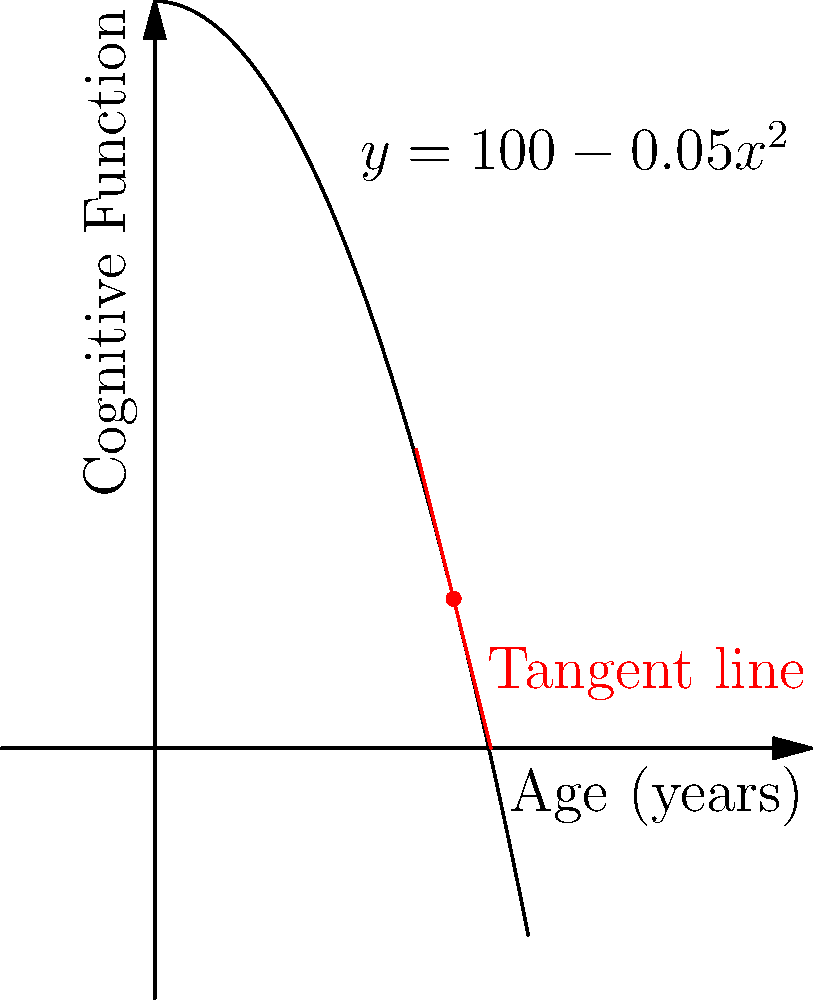Given the curve representing cognitive function over age, $y = 100 - 0.05x^2$, where $y$ is the cognitive function score and $x$ is age in years, determine the instantaneous rate of change in cognitive function at age 40. How does this relate to the concept of cognitive reserve in aging psychology? To find the instantaneous rate of change at age 40, we need to calculate the derivative of the function at x = 40.

1) The given function is $y = 100 - 0.05x^2$

2) To find the derivative, we use the power rule:
   $\frac{dy}{dx} = -0.05 \cdot 2x = -0.1x$

3) At x = 40:
   $\frac{dy}{dx}|_{x=40} = -0.1(40) = -4$

4) This means that at age 40, the cognitive function is decreasing at a rate of 4 points per year.

5) In terms of cognitive reserve, this relates to the idea that individuals with higher cognitive function earlier in life may experience a steeper decline but still maintain higher function compared to those who started lower. The negative slope indicates the natural decline in cognitive function with age, but the rate of decline can vary based on factors like education, lifestyle, and mental stimulation, which contribute to cognitive reserve.

6) The tangent line on the graph (in red) visually represents this instantaneous rate of change, showing the direction and steepness of the decline at age 40.
Answer: -4 points per year 